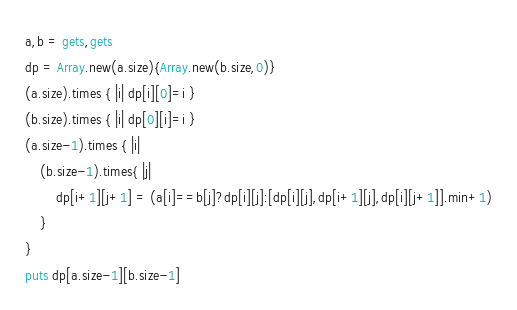<code> <loc_0><loc_0><loc_500><loc_500><_Ruby_>a,b = gets,gets
dp = Array.new(a.size){Array.new(b.size,0)}
(a.size).times { |i| dp[i][0]=i }
(b.size).times { |i| dp[0][i]=i }
(a.size-1).times { |i|
	(b.size-1).times{ |j|
		dp[i+1][j+1] = (a[i]==b[j]?dp[i][j]:[dp[i][j],dp[i+1][j],dp[i][j+1]].min+1)
	}
}
puts dp[a.size-1][b.size-1]</code> 